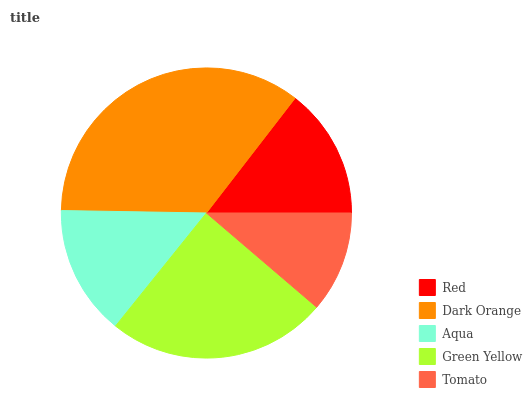Is Tomato the minimum?
Answer yes or no. Yes. Is Dark Orange the maximum?
Answer yes or no. Yes. Is Aqua the minimum?
Answer yes or no. No. Is Aqua the maximum?
Answer yes or no. No. Is Dark Orange greater than Aqua?
Answer yes or no. Yes. Is Aqua less than Dark Orange?
Answer yes or no. Yes. Is Aqua greater than Dark Orange?
Answer yes or no. No. Is Dark Orange less than Aqua?
Answer yes or no. No. Is Red the high median?
Answer yes or no. Yes. Is Red the low median?
Answer yes or no. Yes. Is Dark Orange the high median?
Answer yes or no. No. Is Aqua the low median?
Answer yes or no. No. 